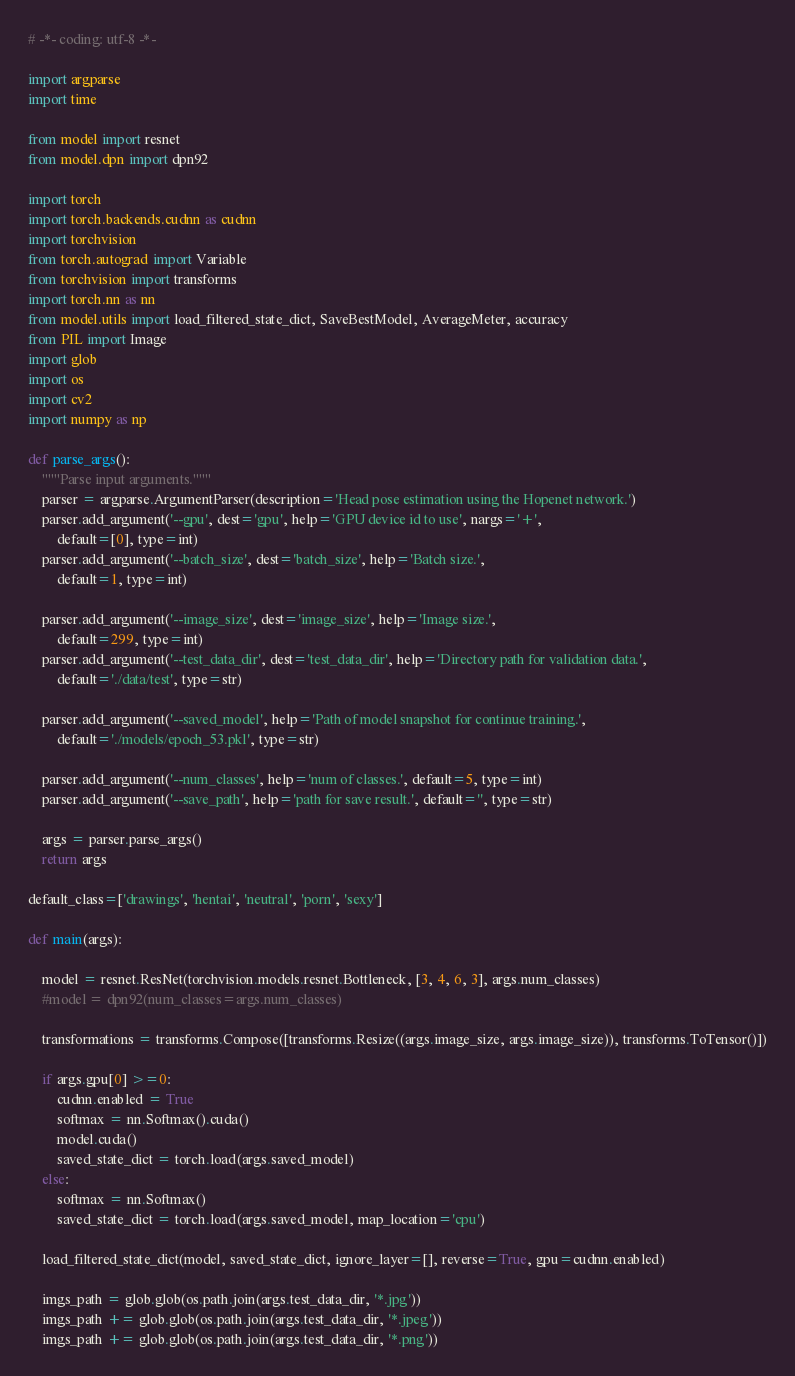Convert code to text. <code><loc_0><loc_0><loc_500><loc_500><_Python_># -*- coding: utf-8 -*-

import argparse
import time

from model import resnet
from model.dpn import dpn92

import torch
import torch.backends.cudnn as cudnn
import torchvision
from torch.autograd import Variable
from torchvision import transforms
import torch.nn as nn
from model.utils import load_filtered_state_dict, SaveBestModel, AverageMeter, accuracy
from PIL import Image
import glob
import os
import cv2
import numpy as np

def parse_args():
    """Parse input arguments."""
    parser = argparse.ArgumentParser(description='Head pose estimation using the Hopenet network.')
    parser.add_argument('--gpu', dest='gpu', help='GPU device id to use', nargs='+', 
        default=[0], type=int)
    parser.add_argument('--batch_size', dest='batch_size', help='Batch size.',
        default=1, type=int)
        
    parser.add_argument('--image_size', dest='image_size', help='Image size.',
        default=299, type=int)
    parser.add_argument('--test_data_dir', dest='test_data_dir', help='Directory path for validation data.',
        default='./data/test', type=str)
        
    parser.add_argument('--saved_model', help='Path of model snapshot for continue training.',
        default='./models/epoch_53.pkl', type=str)

    parser.add_argument('--num_classes', help='num of classes.', default=5, type=int)
    parser.add_argument('--save_path', help='path for save result.', default='', type=str)

    args = parser.parse_args()
    return args

default_class=['drawings', 'hentai', 'neutral', 'porn', 'sexy']

def main(args):    
    
    model = resnet.ResNet(torchvision.models.resnet.Bottleneck, [3, 4, 6, 3], args.num_classes)    
    #model = dpn92(num_classes=args.num_classes)

    transformations = transforms.Compose([transforms.Resize((args.image_size, args.image_size)), transforms.ToTensor()])
    
    if args.gpu[0] >=0:        
        cudnn.enabled = True 
        softmax = nn.Softmax().cuda()
        model.cuda()
        saved_state_dict = torch.load(args.saved_model)
    else:
        softmax = nn.Softmax()        
        saved_state_dict = torch.load(args.saved_model, map_location='cpu')

    load_filtered_state_dict(model, saved_state_dict, ignore_layer=[], reverse=True, gpu=cudnn.enabled)

    imgs_path = glob.glob(os.path.join(args.test_data_dir, '*.jpg'))
    imgs_path += glob.glob(os.path.join(args.test_data_dir, '*.jpeg'))
    imgs_path += glob.glob(os.path.join(args.test_data_dir, '*.png'))
</code> 